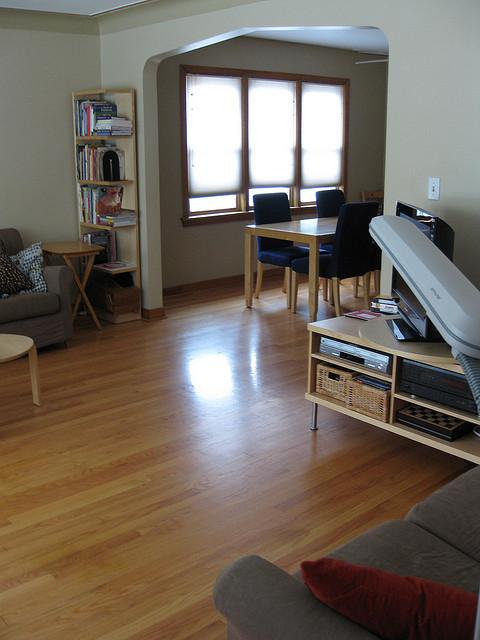Are there curtains on the window?
Quick response, please. No. Where is the television?
Concise answer only. Table. How many doors lead to the room?
Quick response, please. 1. What room is this?
Write a very short answer. Living room. What is the red chair in front of?
Keep it brief. Nothing. What color are the chairs at the table?
Keep it brief. Blue. What is in the corner of room?
Answer briefly. Bookshelf. Is the floor carpeted?
Short answer required. No. Why did this picture only capture the side of the room?
Short answer required. Angle. If this picture was taken at sunrise, which direction do the windows face?
Answer briefly. East. Is there carpet on the floor?
Answer briefly. No. Is this a living room?
Short answer required. Yes. How many pillows on the sofa?
Be succinct. 1. 